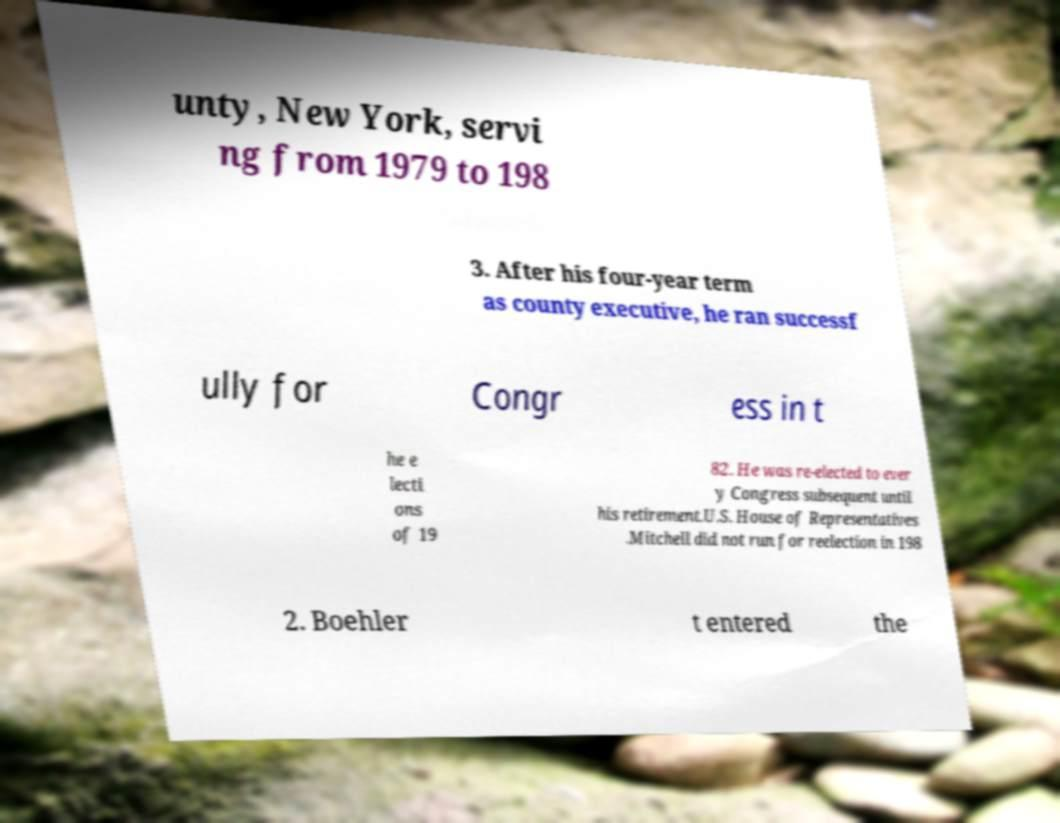What political roles did the person mentioned in the image text serve in? The image text mentions an individual serving as county executive from 1979 to 1983 and subsequently running successfully for U.S. Congress in 1982 where he was re-elected several times until his retirement. It also mentions Mitchell, who did not run for reelection in 1982, possibly referring to another political figure or the same individual under a different name context. 